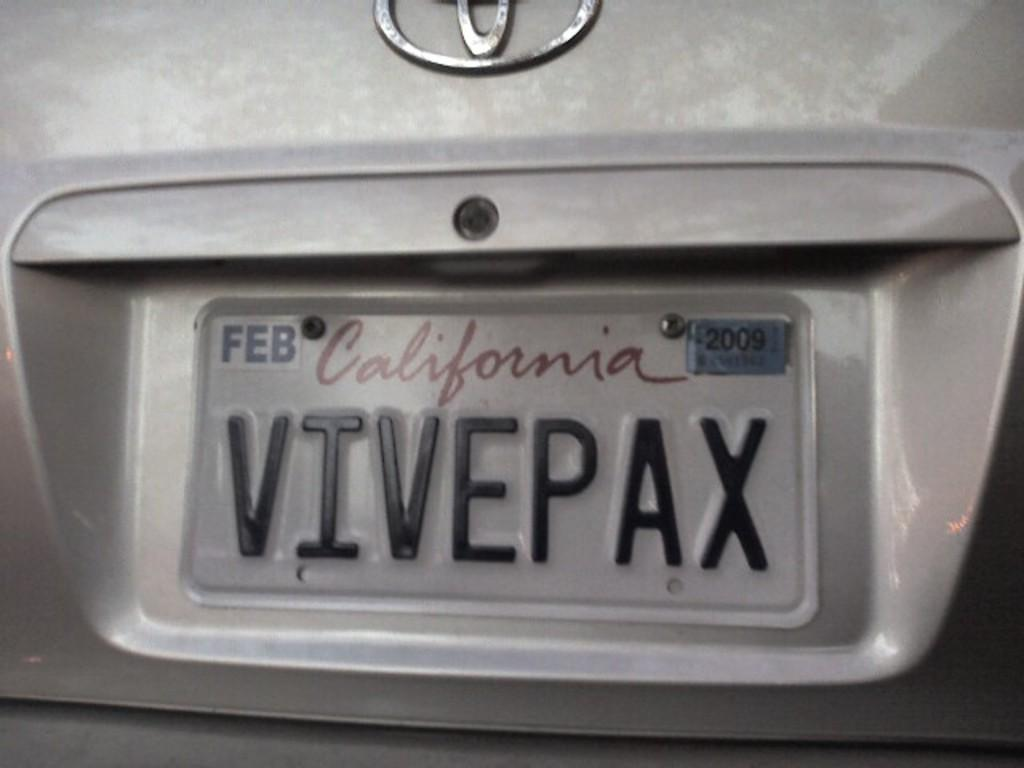Provide a one-sentence caption for the provided image. The California license plate has expired tags on it. 